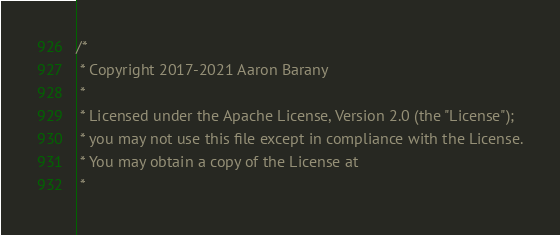Convert code to text. <code><loc_0><loc_0><loc_500><loc_500><_C_>/*
 * Copyright 2017-2021 Aaron Barany
 *
 * Licensed under the Apache License, Version 2.0 (the "License");
 * you may not use this file except in compliance with the License.
 * You may obtain a copy of the License at
 *</code> 